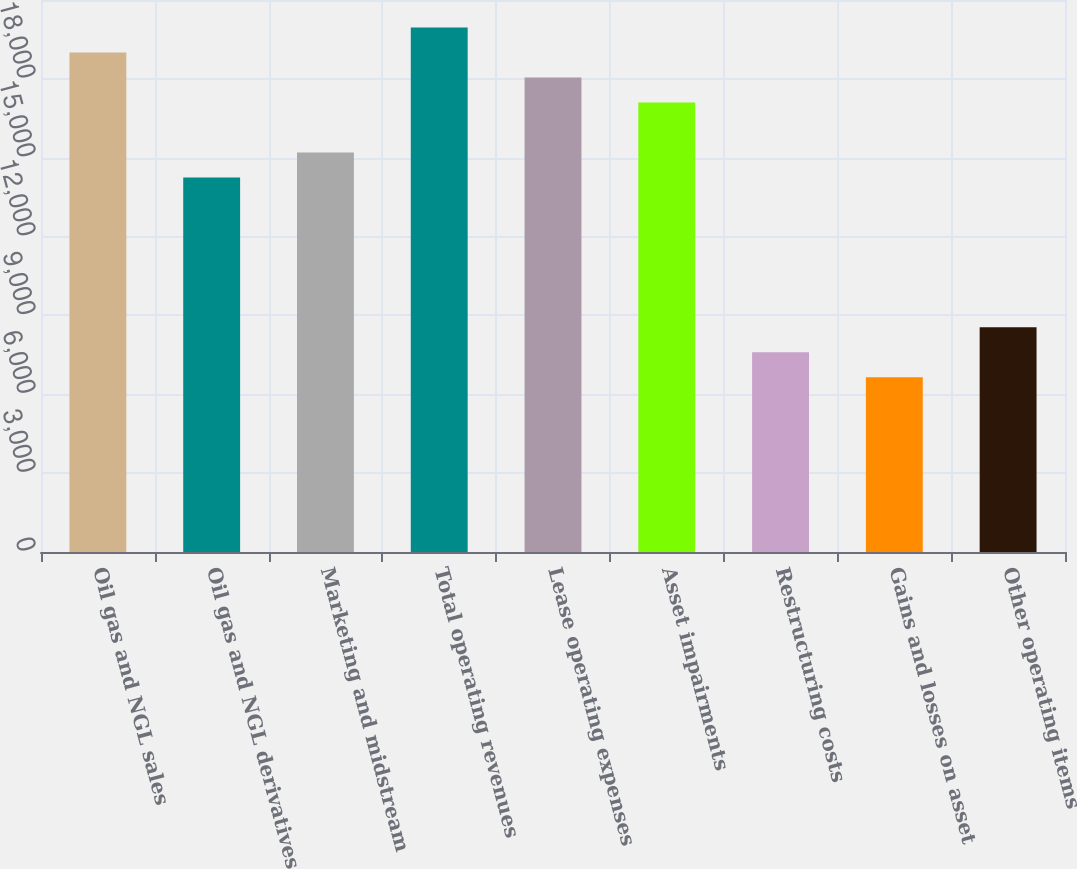Convert chart. <chart><loc_0><loc_0><loc_500><loc_500><bar_chart><fcel>Oil gas and NGL sales<fcel>Oil gas and NGL derivatives<fcel>Marketing and midstream<fcel>Total operating revenues<fcel>Lease operating expenses<fcel>Asset impairments<fcel>Restructuring costs<fcel>Gains and losses on asset<fcel>Other operating items<nl><fcel>19001.5<fcel>14251.2<fcel>15201.3<fcel>19951.5<fcel>18051.4<fcel>17101.4<fcel>7600.87<fcel>6650.82<fcel>8550.92<nl></chart> 